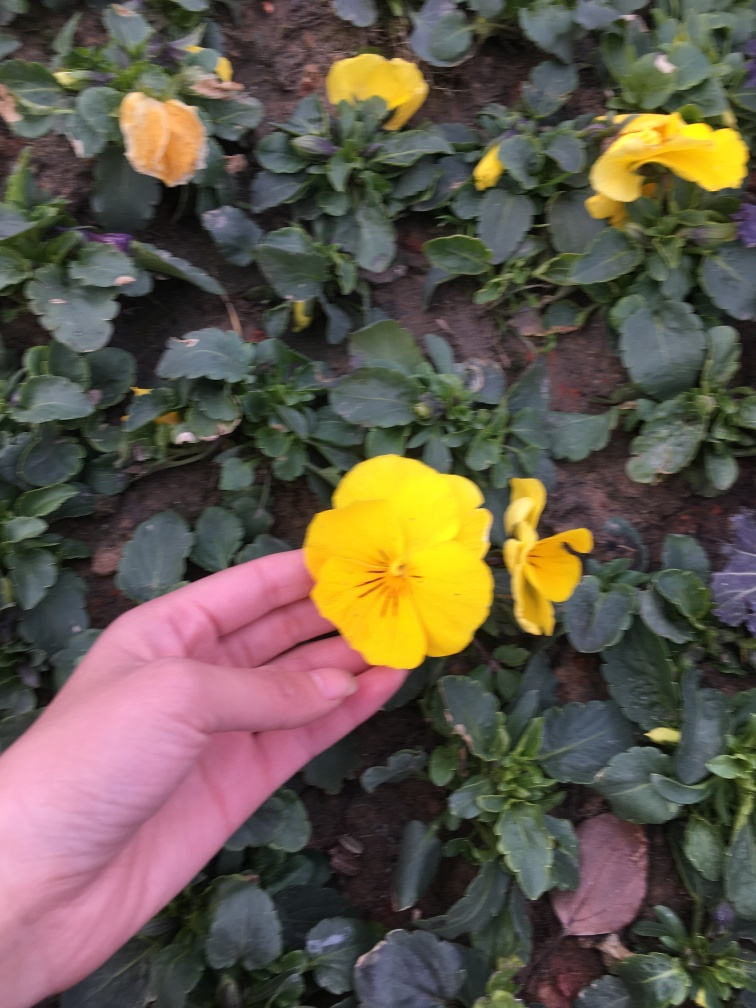How does this image reflect the concept of growth? The image metaphorically illustrates growth in the way the hand holds a blooming flower, contrasting it with the soil and other flowers in the background. It demonstrates a moment of care and nurturing that is essential for the development and flourishing of life. Can taking care of plants have any benefits for people? Absolutely, taking care of plants can have several benefits including reducing stress, enhancing focus, and improving air quality. It also fosters a sense of responsibility and connection with nature, providing psychological well-being and a means for cultivating patience and mindfulness. 